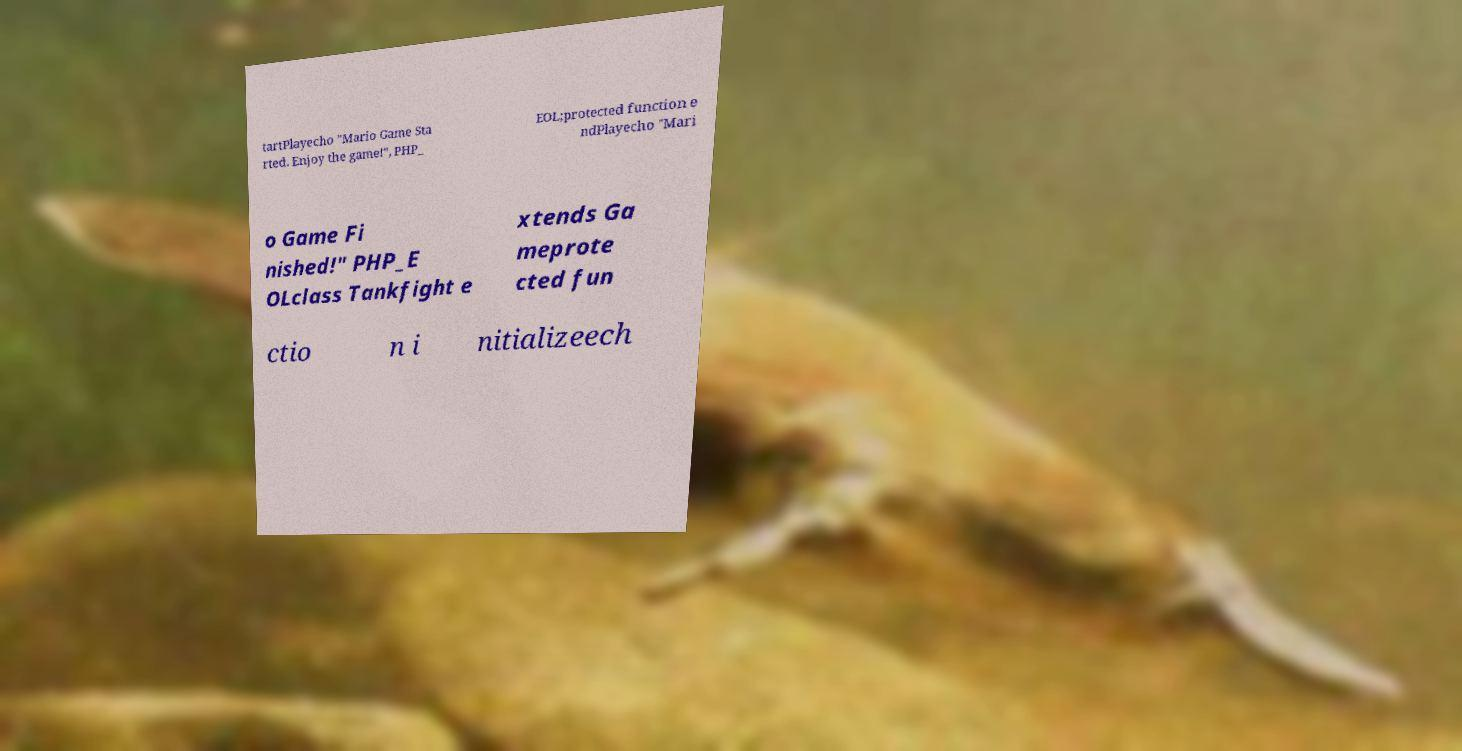Can you read and provide the text displayed in the image?This photo seems to have some interesting text. Can you extract and type it out for me? tartPlayecho "Mario Game Sta rted. Enjoy the game!", PHP_ EOL;protected function e ndPlayecho "Mari o Game Fi nished!" PHP_E OLclass Tankfight e xtends Ga meprote cted fun ctio n i nitializeech 